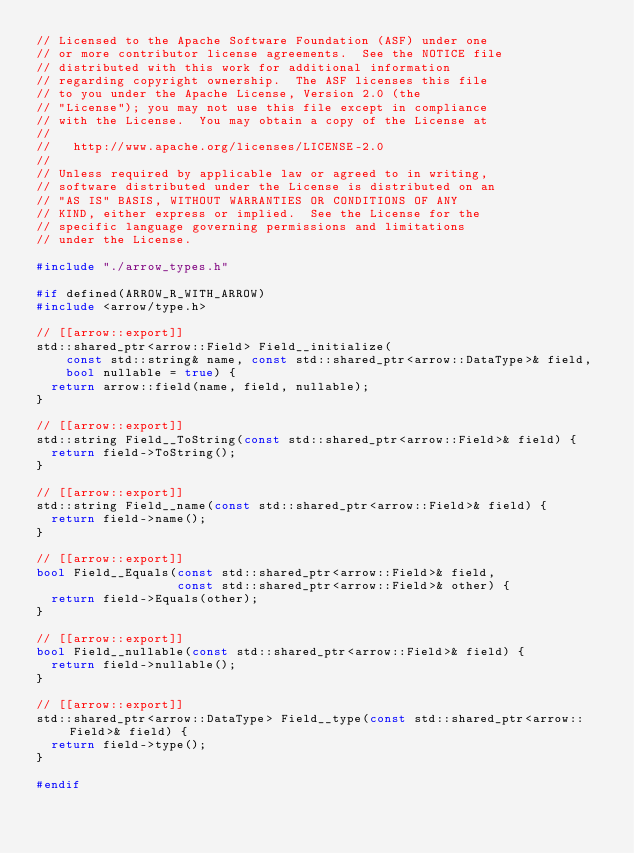<code> <loc_0><loc_0><loc_500><loc_500><_C++_>// Licensed to the Apache Software Foundation (ASF) under one
// or more contributor license agreements.  See the NOTICE file
// distributed with this work for additional information
// regarding copyright ownership.  The ASF licenses this file
// to you under the Apache License, Version 2.0 (the
// "License"); you may not use this file except in compliance
// with the License.  You may obtain a copy of the License at
//
//   http://www.apache.org/licenses/LICENSE-2.0
//
// Unless required by applicable law or agreed to in writing,
// software distributed under the License is distributed on an
// "AS IS" BASIS, WITHOUT WARRANTIES OR CONDITIONS OF ANY
// KIND, either express or implied.  See the License for the
// specific language governing permissions and limitations
// under the License.

#include "./arrow_types.h"

#if defined(ARROW_R_WITH_ARROW)
#include <arrow/type.h>

// [[arrow::export]]
std::shared_ptr<arrow::Field> Field__initialize(
    const std::string& name, const std::shared_ptr<arrow::DataType>& field,
    bool nullable = true) {
  return arrow::field(name, field, nullable);
}

// [[arrow::export]]
std::string Field__ToString(const std::shared_ptr<arrow::Field>& field) {
  return field->ToString();
}

// [[arrow::export]]
std::string Field__name(const std::shared_ptr<arrow::Field>& field) {
  return field->name();
}

// [[arrow::export]]
bool Field__Equals(const std::shared_ptr<arrow::Field>& field,
                   const std::shared_ptr<arrow::Field>& other) {
  return field->Equals(other);
}

// [[arrow::export]]
bool Field__nullable(const std::shared_ptr<arrow::Field>& field) {
  return field->nullable();
}

// [[arrow::export]]
std::shared_ptr<arrow::DataType> Field__type(const std::shared_ptr<arrow::Field>& field) {
  return field->type();
}

#endif
</code> 